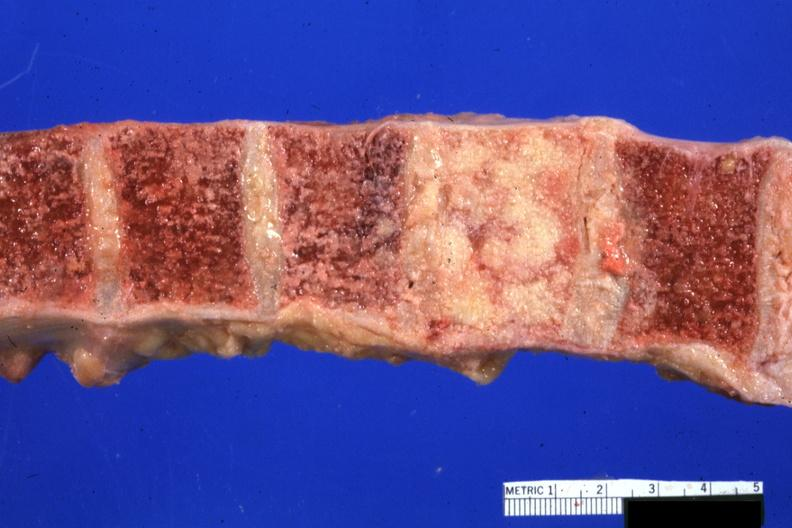does this image show vertebral bodies with one completely replaced by neoplasm excellent photo 68yowm cord compression?
Answer the question using a single word or phrase. Yes 